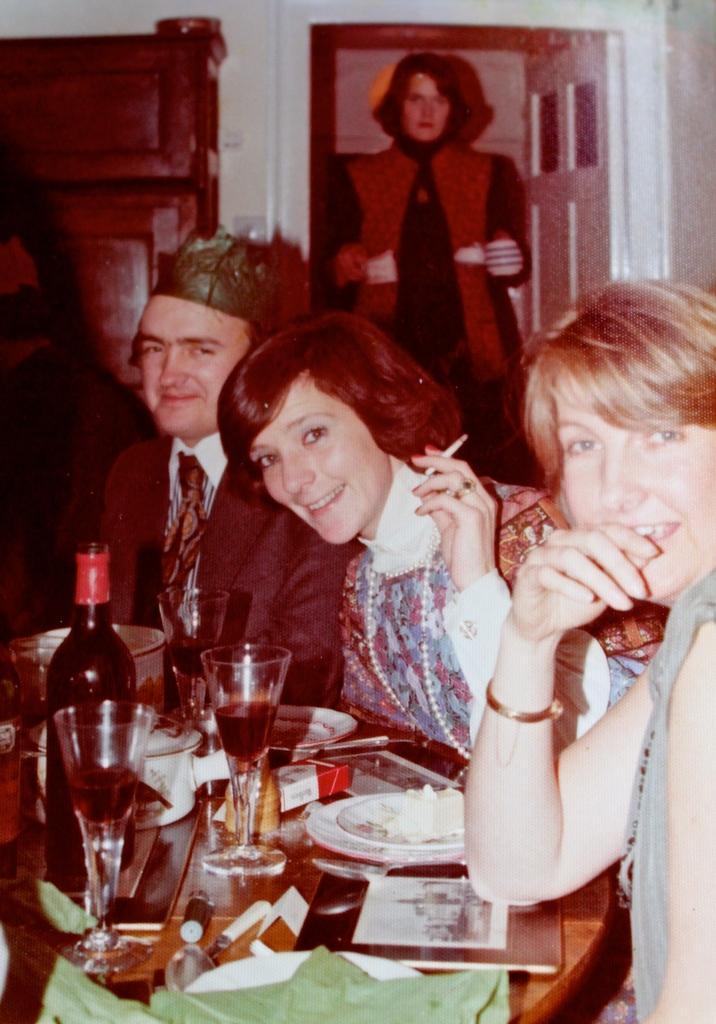In one or two sentences, can you explain what this image depicts? In this picture there are people those who are sitting around the table in the image, table contains glasses, bottle, plates, and other items and there are cupboards in the background area of the image, there is a lady who is standing at the door in the background area of the image. 